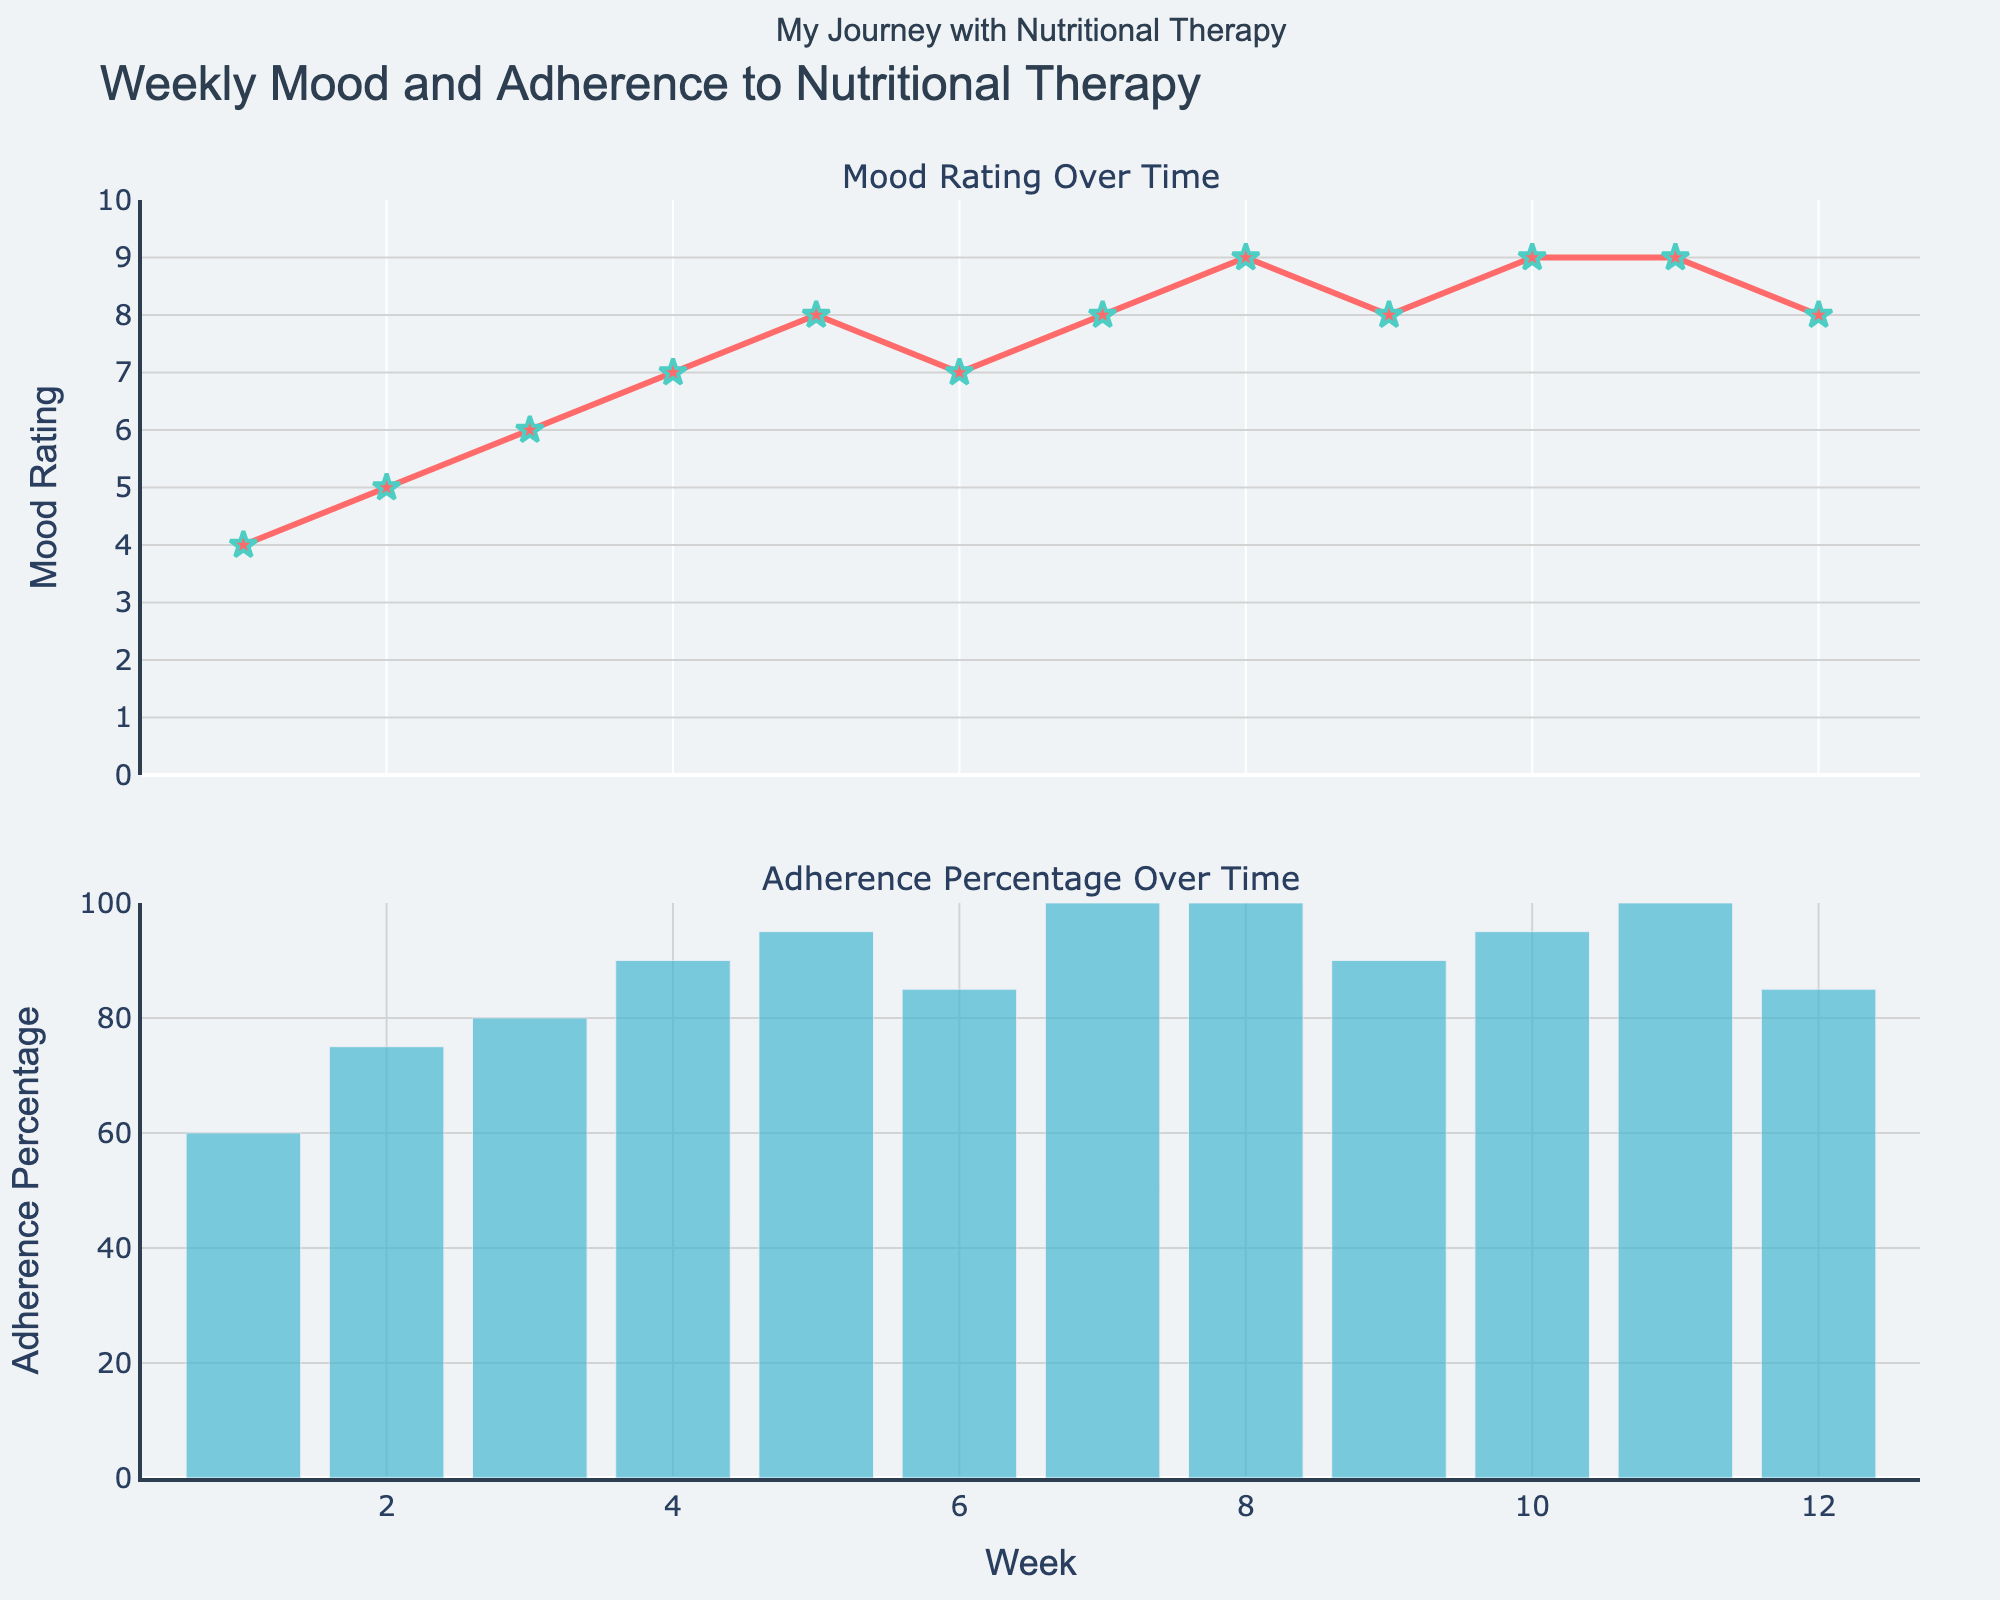What is the title of the figure? The title of a figure is usually presented prominently at the top of the plot. In this case, the title "Performance Impact of CSS Selectors" can be seen clearly in large, bold text.
Answer: Performance Impact of CSS Selectors What do the bars represent in each subplot? By analyzing the distribution of the bars across multiple subplots and considering their horizontal layout, we can infer that each bar represents the performance impact (in milliseconds) of a CSS selector at different complexity levels.
Answer: Performance impact in milliseconds Which selector type has the highest performance impact in the 'Simple' complexity level? In the 'Simple' plot, look for the bar that extends the furthest to the right. The Universal selector has the highest value, with a performance impact of 0.10 milliseconds.
Answer: Universal How many different CSS selectors are compared in the figure? By counting the unique y-axis labels across all subplots, you can see there are ten different CSS selectors being compared: ID, Class, Attribute, Pseudo-class, Descendant, Child, Adjacent Sibling, General Sibling, Universal, and Negation.
Answer: 10 Does the 'Pseudo-class' selector type have higher performance impact in 'Moderate' or 'Complex' complexity level? By checking the length of the 'Pseudo-class' bars in both the 'Moderate' and 'Complex' subplots, you see that the bar is longer in the 'Complex' plot (0.35 ms) than in the 'Moderate' plot (0.15 ms).
Answer: Complex What is the difference in performance impact between 'ID' and 'Class' selectors in the 'Moderate' complexity level? In the 'Moderate' subplot, find the x-values for 'ID' (0.05 ms) and 'Class' (0.08 ms), and calculate the difference. This gives 0.08 - 0.05 = 0.03 ms.
Answer: 0.03 ms Which complexity level generally shows the highest performance impact for all selectors? By examining the overall bar lengths across the three subplots, it becomes clear that the 'Complex' level has the longest bars, indicating the highest performance impact for all selectors.
Answer: Complex What is the performance impact of the 'Negation' selector in the 'Simple' complexity level? Locate the 'Negation' selector in the 'Simple' complexity subplot and check its x-value, which is 0.12 milliseconds.
Answer: 0.12 ms How does the 'Descendant' selector's performance impact differ between 'Simple' and 'Complex' complexity levels? Compare the lengths of the bars corresponding to the 'Descendant' selector in both the 'Simple' (0.06 ms) and 'Complex' (0.45 ms) subplots. The difference is 0.45 - 0.06 = 0.39 ms.
Answer: 0.39 ms Which selector type has the least variation in performance impact across all three complexity levels? By comparing the length of the bars representing each selector in all three subplots, the 'ID' selector shows the smallest range: 0.02 ms in 'Simple', 0.05 ms in 'Moderate', and 0.12 ms in 'Complex', resulting in a range of 0.10 ms.
Answer: ID 